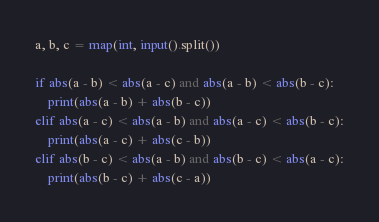<code> <loc_0><loc_0><loc_500><loc_500><_Python_>a, b, c = map(int, input().split())

if abs(a - b) < abs(a - c) and abs(a - b) < abs(b - c):
    print(abs(a - b) + abs(b - c))
elif abs(a - c) < abs(a - b) and abs(a - c) < abs(b - c):
    print(abs(a - c) + abs(c - b))
elif abs(b - c) < abs(a - b) and abs(b - c) < abs(a - c):
    print(abs(b - c) + abs(c - a))

</code> 